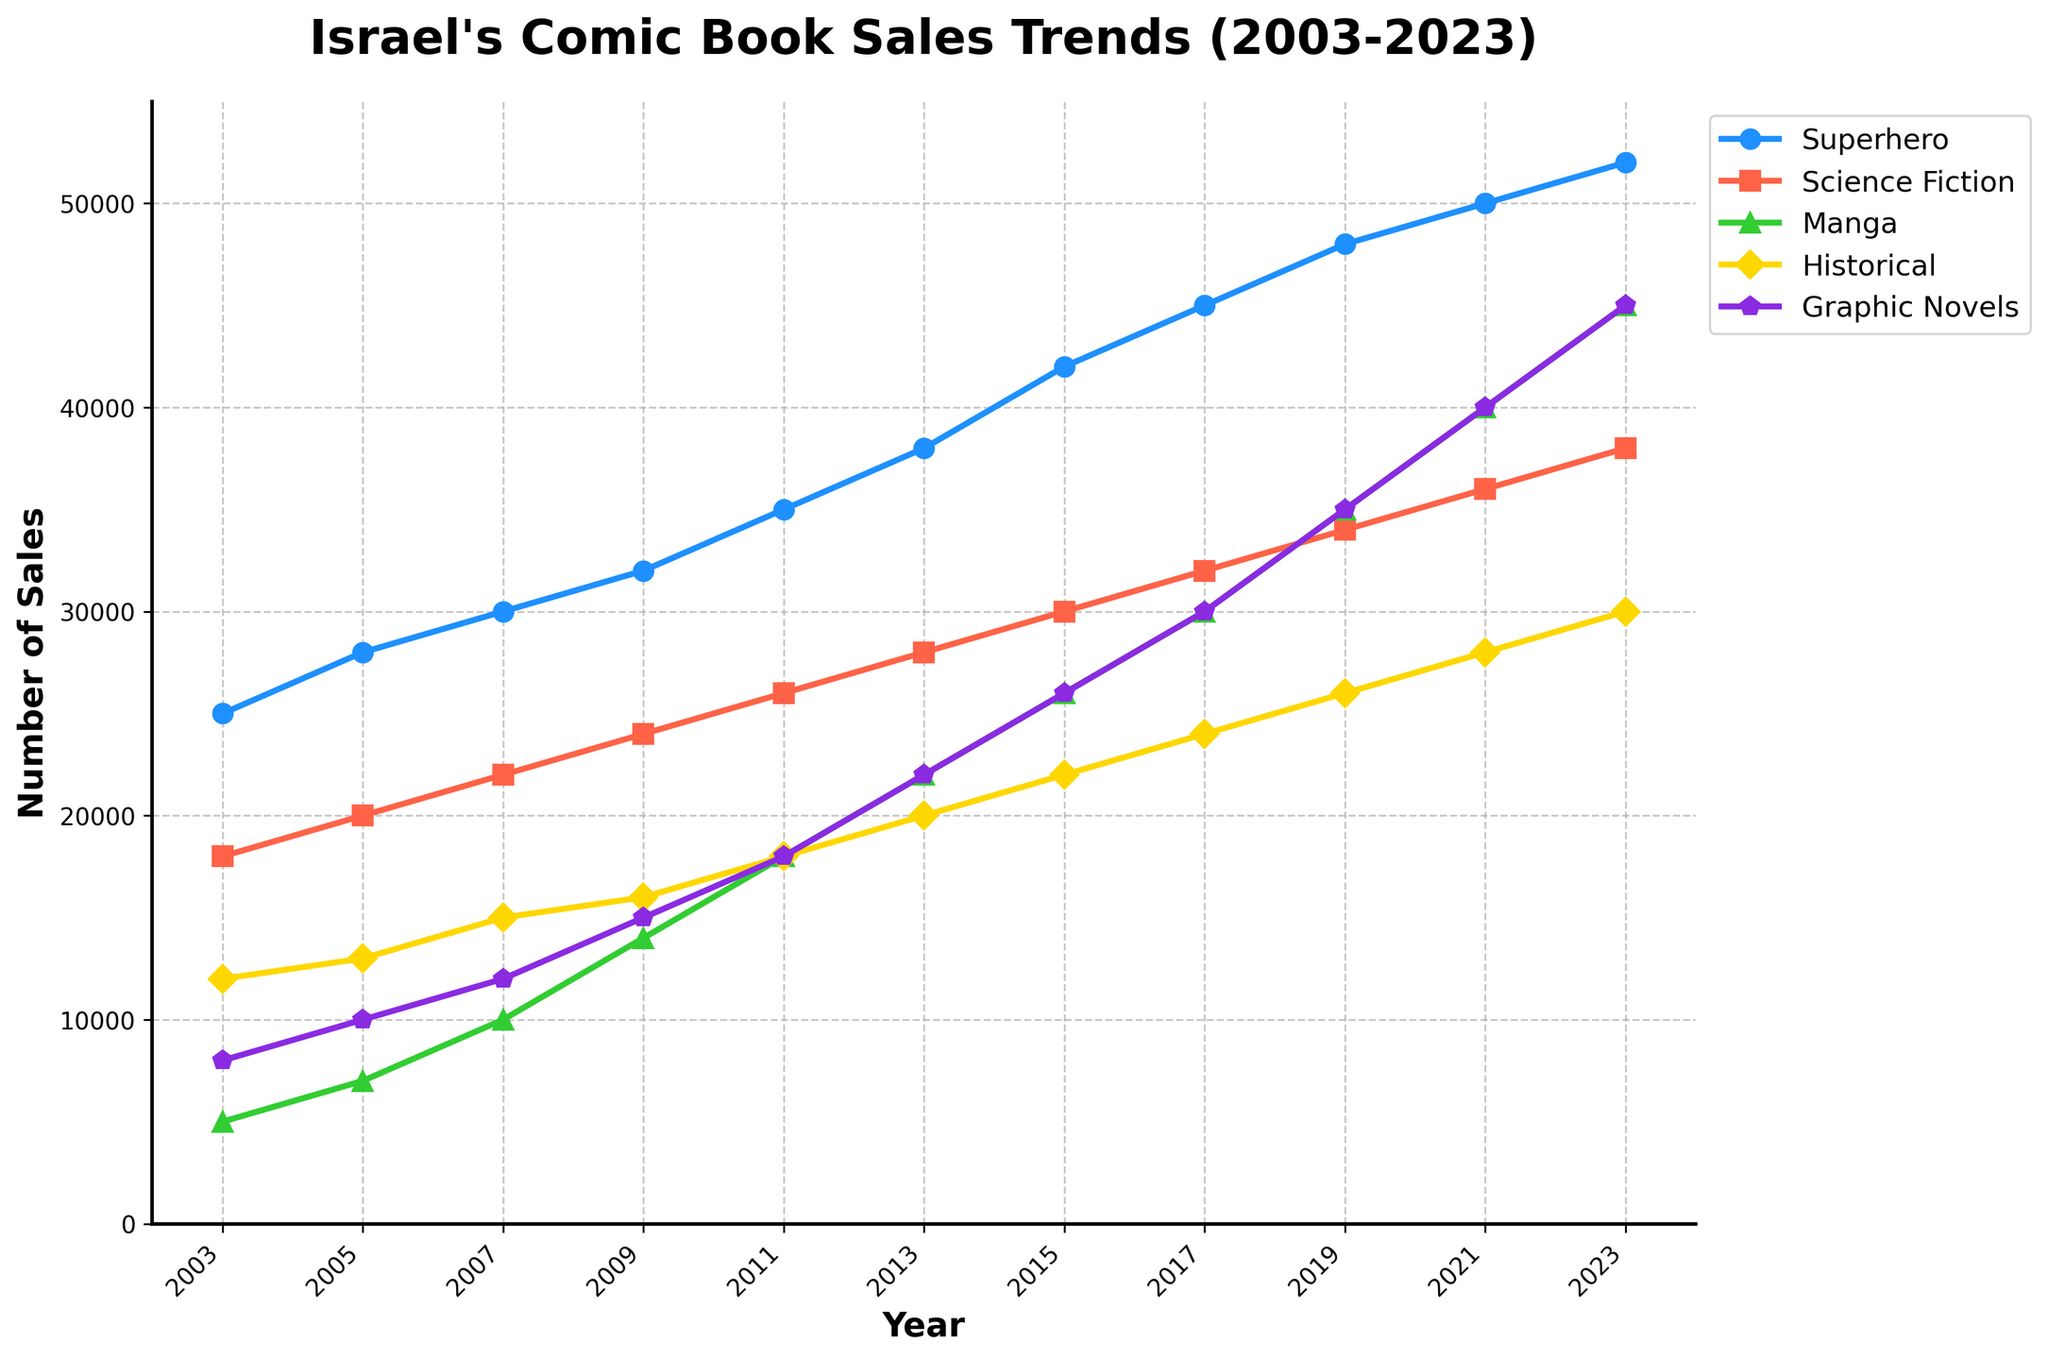What's the general trend in superhero comic book sales from 2003 to 2023? The superhero comic book sales show a steady increase over the period from 2003 to 2023. Starting at 25,000 in 2003 and reaching 52,000 in 2023, indicating continuous growth.
Answer: Continuous growth Which genre had the most significant increase in sales from 2003 to 2023? Comparing the increase for each genre: Superhero (52,000 - 25,000 = 27,000), Science Fiction (38,000 - 18,000 = 20,000), Manga (45,000 - 5,000 = 40,000), Historical (30,000 - 12,000 = 18,000), and Graphic Novels (45,000 - 8,000 = 37,000). Manga had the most significant increase.
Answer: Manga In what year did historical comic book sales first exceed 20,000? Looking at the historical data for the 'Historical' genre: 12,000 (2003), 13,000 (2005), 15,000 (2007), 16,000 (2009), 18,000 (2011), 20,000 (2013). Therefore, sales first exceeded 20,000 in 2015 (22,000).
Answer: 2015 How did Manga comic book sales change between 2019 and 2021? Sales for Manga were 35,000 in 2019 and increased to 40,000 in 2021. Calculating the difference: 40,000 - 35,000 = 5,000, so Manga comic book sales increased by 5,000.
Answer: Increased by 5,000 Which genre had the smallest sales growth from 2009 to 2011? Comparing sales from 2009 to 2011 for each genre: Superhero (35,000 - 32,000 = 3,000), Science Fiction (26,000 - 24,000 = 2,000), Manga (18,000 - 14,000 = 4,000), Historical (18,000 - 16,000 = 2,000), Graphic Novels (18,000 - 15,000 = 3,000). Both Science Fiction and Historical had the smallest growth of 2,000 each.
Answer: Science Fiction and Historical What was the total number of comic book sales for all genres combined in 2023? Summing up the sales for 2023: Superhero (52,000) + Science Fiction (38,000) + Manga (45,000) + Historical (30,000) + Graphic Novels (45,000) = 210,000.
Answer: 210,000 Which genre had the slowest growth rate in sales from 2003 to 2023? Calculating the growth rate per year for each genre over the 20-year period: Superhero (27,000/20=1,350), Science Fiction (20,000/20=1,000), Manga (40,000/20=2,000), Historical (18,000/20=900), and Graphic Novels (37,000/20=1,850). Historical had the slowest growth rate.
Answer: Historical In 2021, how did the sales of graphic novels compare to those of superhero comics? In 2021, graphic novels had sales of 40,000, while superhero comic books had sales of 50,000. Therefore, superhero comic books had higher sales.
Answer: Superhero had higher sales 